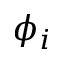<formula> <loc_0><loc_0><loc_500><loc_500>\phi _ { i }</formula> 